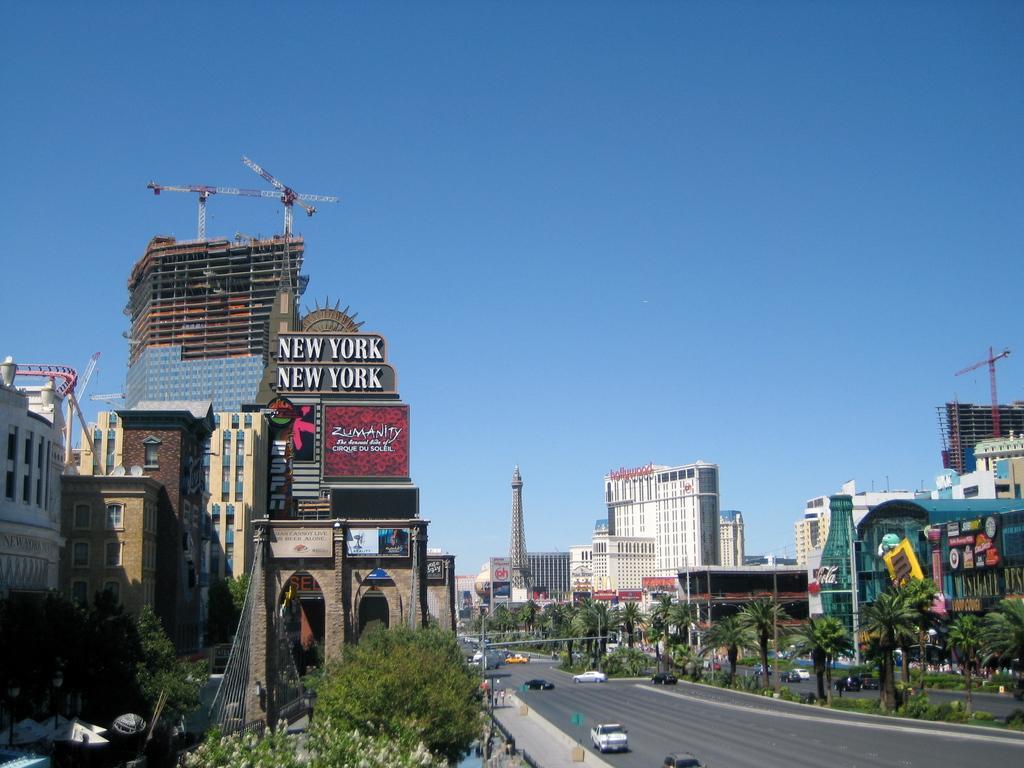In one or two sentences, can you explain what this image depicts? This is a street view I can see buildings, trees, cars on both sides of the image with a road. I can see a tower in the center of the image. At the top of the image I can see the sky.  